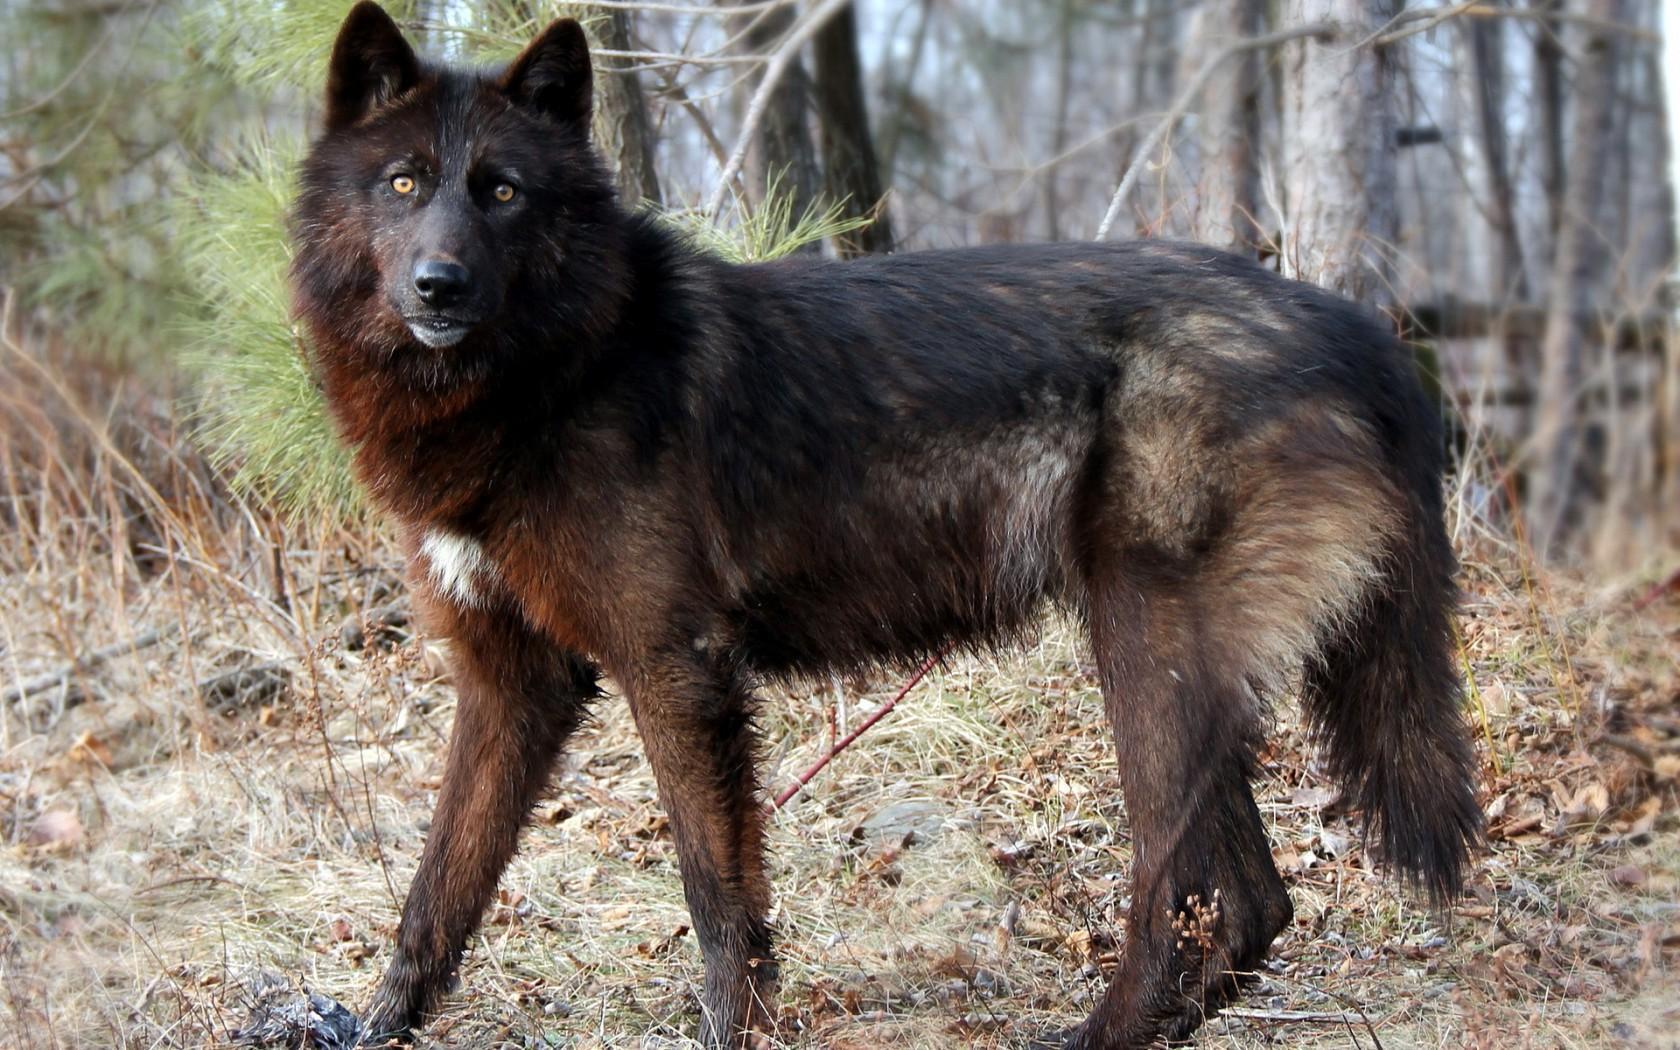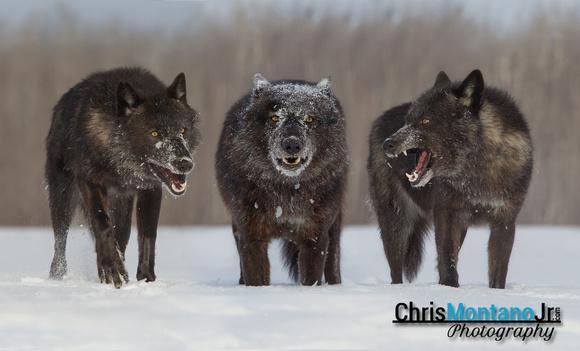The first image is the image on the left, the second image is the image on the right. Given the left and right images, does the statement "There is exactly one animal in the image on the right." hold true? Answer yes or no. No. 